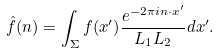<formula> <loc_0><loc_0><loc_500><loc_500>\hat { f } ( n ) = \int _ { \Sigma } f ( x ^ { \prime } ) \frac { e ^ { - 2 \pi i n \cdot x ^ { \prime } } } { L _ { 1 } L _ { 2 } } d x ^ { \prime } .</formula> 